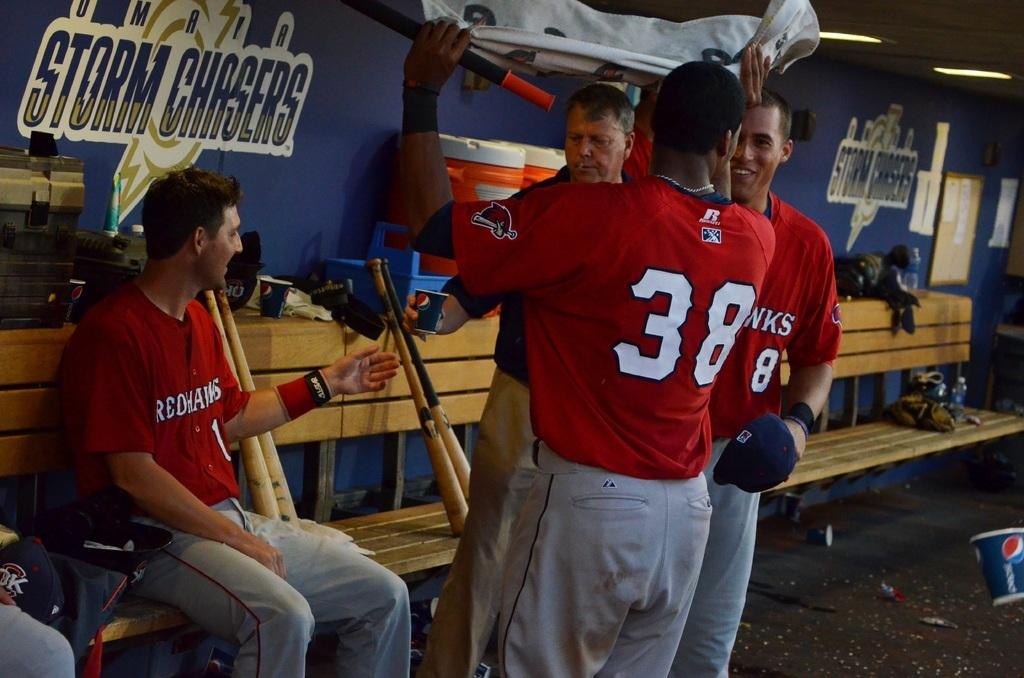<image>
Write a terse but informative summary of the picture. A man sits on a bench in front of a wall that says "Storm Chasers." 